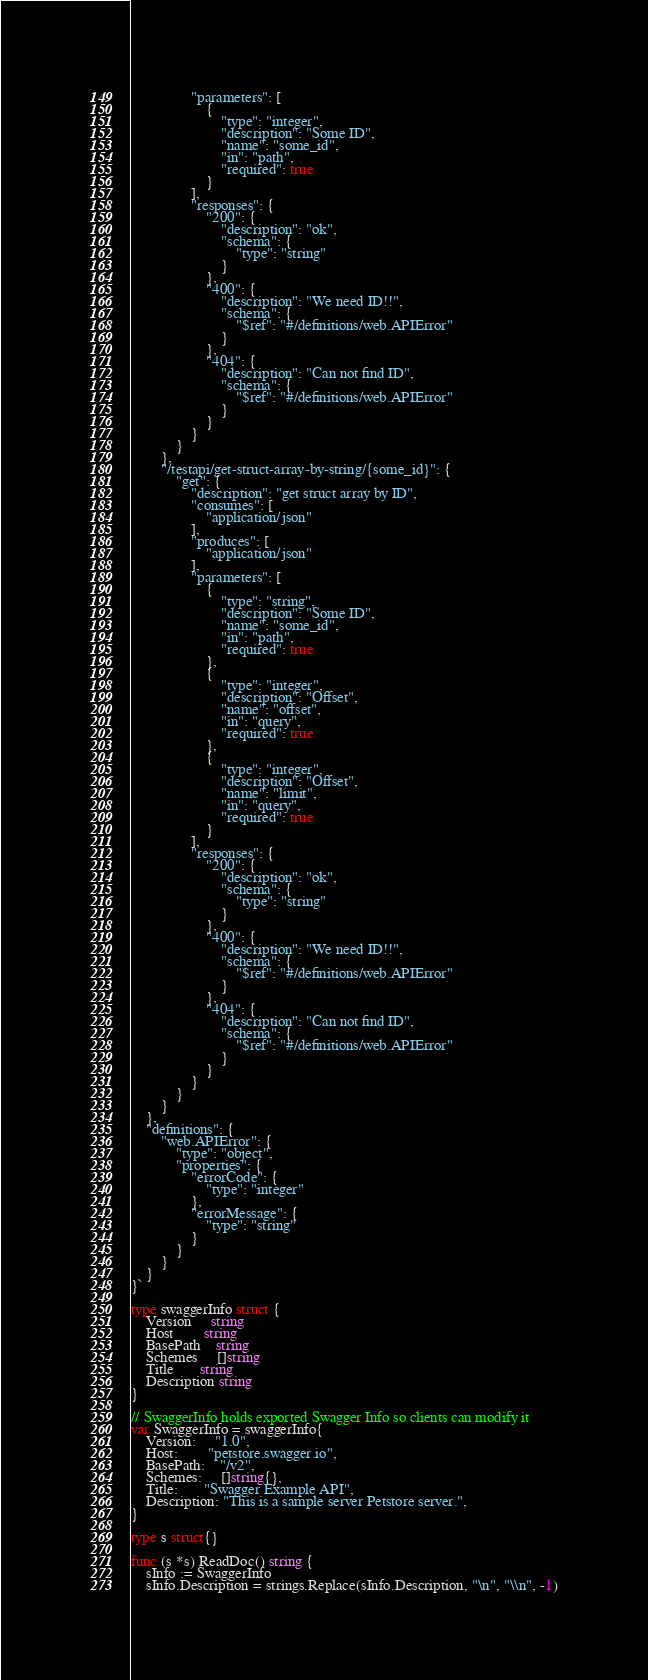<code> <loc_0><loc_0><loc_500><loc_500><_Go_>                "parameters": [
                    {
                        "type": "integer",
                        "description": "Some ID",
                        "name": "some_id",
                        "in": "path",
                        "required": true
                    }
                ],
                "responses": {
                    "200": {
                        "description": "ok",
                        "schema": {
                            "type": "string"
                        }
                    },
                    "400": {
                        "description": "We need ID!!",
                        "schema": {
                            "$ref": "#/definitions/web.APIError"
                        }
                    },
                    "404": {
                        "description": "Can not find ID",
                        "schema": {
                            "$ref": "#/definitions/web.APIError"
                        }
                    }
                }
            }
        },
        "/testapi/get-struct-array-by-string/{some_id}": {
            "get": {
                "description": "get struct array by ID",
                "consumes": [
                    "application/json"
                ],
                "produces": [
                    "application/json"
                ],
                "parameters": [
                    {
                        "type": "string",
                        "description": "Some ID",
                        "name": "some_id",
                        "in": "path",
                        "required": true
                    },
                    {
                        "type": "integer",
                        "description": "Offset",
                        "name": "offset",
                        "in": "query",
                        "required": true
                    },
                    {
                        "type": "integer",
                        "description": "Offset",
                        "name": "limit",
                        "in": "query",
                        "required": true
                    }
                ],
                "responses": {
                    "200": {
                        "description": "ok",
                        "schema": {
                            "type": "string"
                        }
                    },
                    "400": {
                        "description": "We need ID!!",
                        "schema": {
                            "$ref": "#/definitions/web.APIError"
                        }
                    },
                    "404": {
                        "description": "Can not find ID",
                        "schema": {
                            "$ref": "#/definitions/web.APIError"
                        }
                    }
                }
            }
        }
    },
    "definitions": {
        "web.APIError": {
            "type": "object",
            "properties": {
                "errorCode": {
                    "type": "integer"
                },
                "errorMessage": {
                    "type": "string"
                }
            }
        }
    }
}`

type swaggerInfo struct {
	Version     string
	Host        string
	BasePath    string
	Schemes     []string
	Title       string
	Description string
}

// SwaggerInfo holds exported Swagger Info so clients can modify it
var SwaggerInfo = swaggerInfo{
	Version:     "1.0",
	Host:        "petstore.swagger.io",
	BasePath:    "/v2",
	Schemes:     []string{},
	Title:       "Swagger Example API",
	Description: "This is a sample server Petstore server.",
}

type s struct{}

func (s *s) ReadDoc() string {
	sInfo := SwaggerInfo
	sInfo.Description = strings.Replace(sInfo.Description, "\n", "\\n", -1)
</code> 